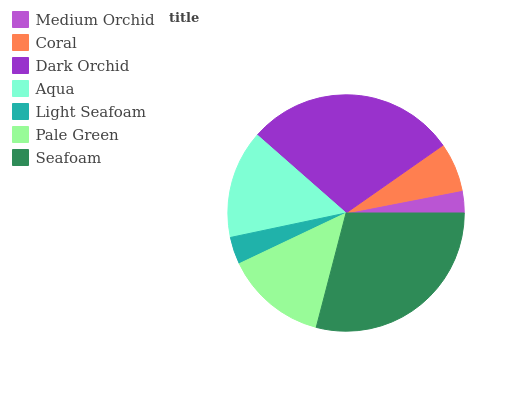Is Medium Orchid the minimum?
Answer yes or no. Yes. Is Seafoam the maximum?
Answer yes or no. Yes. Is Coral the minimum?
Answer yes or no. No. Is Coral the maximum?
Answer yes or no. No. Is Coral greater than Medium Orchid?
Answer yes or no. Yes. Is Medium Orchid less than Coral?
Answer yes or no. Yes. Is Medium Orchid greater than Coral?
Answer yes or no. No. Is Coral less than Medium Orchid?
Answer yes or no. No. Is Pale Green the high median?
Answer yes or no. Yes. Is Pale Green the low median?
Answer yes or no. Yes. Is Dark Orchid the high median?
Answer yes or no. No. Is Aqua the low median?
Answer yes or no. No. 